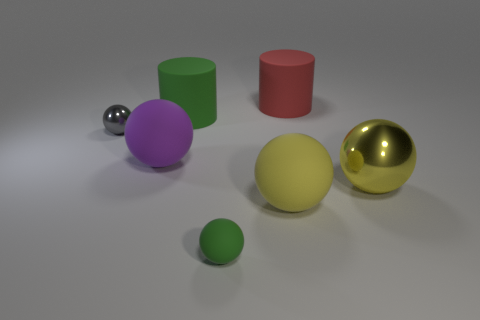There is a gray shiny thing; are there any green objects behind it?
Provide a short and direct response. Yes. How many other objects are there of the same shape as the gray metallic object?
Provide a short and direct response. 4. What color is the matte sphere that is the same size as the purple thing?
Offer a very short reply. Yellow. Is the number of green objects that are on the right side of the big red object less than the number of big matte balls that are in front of the tiny green ball?
Keep it short and to the point. No. What number of cylinders are in front of the large rubber cylinder on the right side of the green thing that is behind the gray metallic ball?
Provide a short and direct response. 1. The gray object that is the same shape as the purple thing is what size?
Provide a short and direct response. Small. Is there any other thing that is the same size as the red matte thing?
Make the answer very short. Yes. Are there fewer large red objects that are on the left side of the gray metallic object than large balls?
Your response must be concise. Yes. Does the small green thing have the same shape as the large red thing?
Give a very brief answer. No. There is a big metal object that is the same shape as the tiny metal object; what color is it?
Your answer should be very brief. Yellow. 